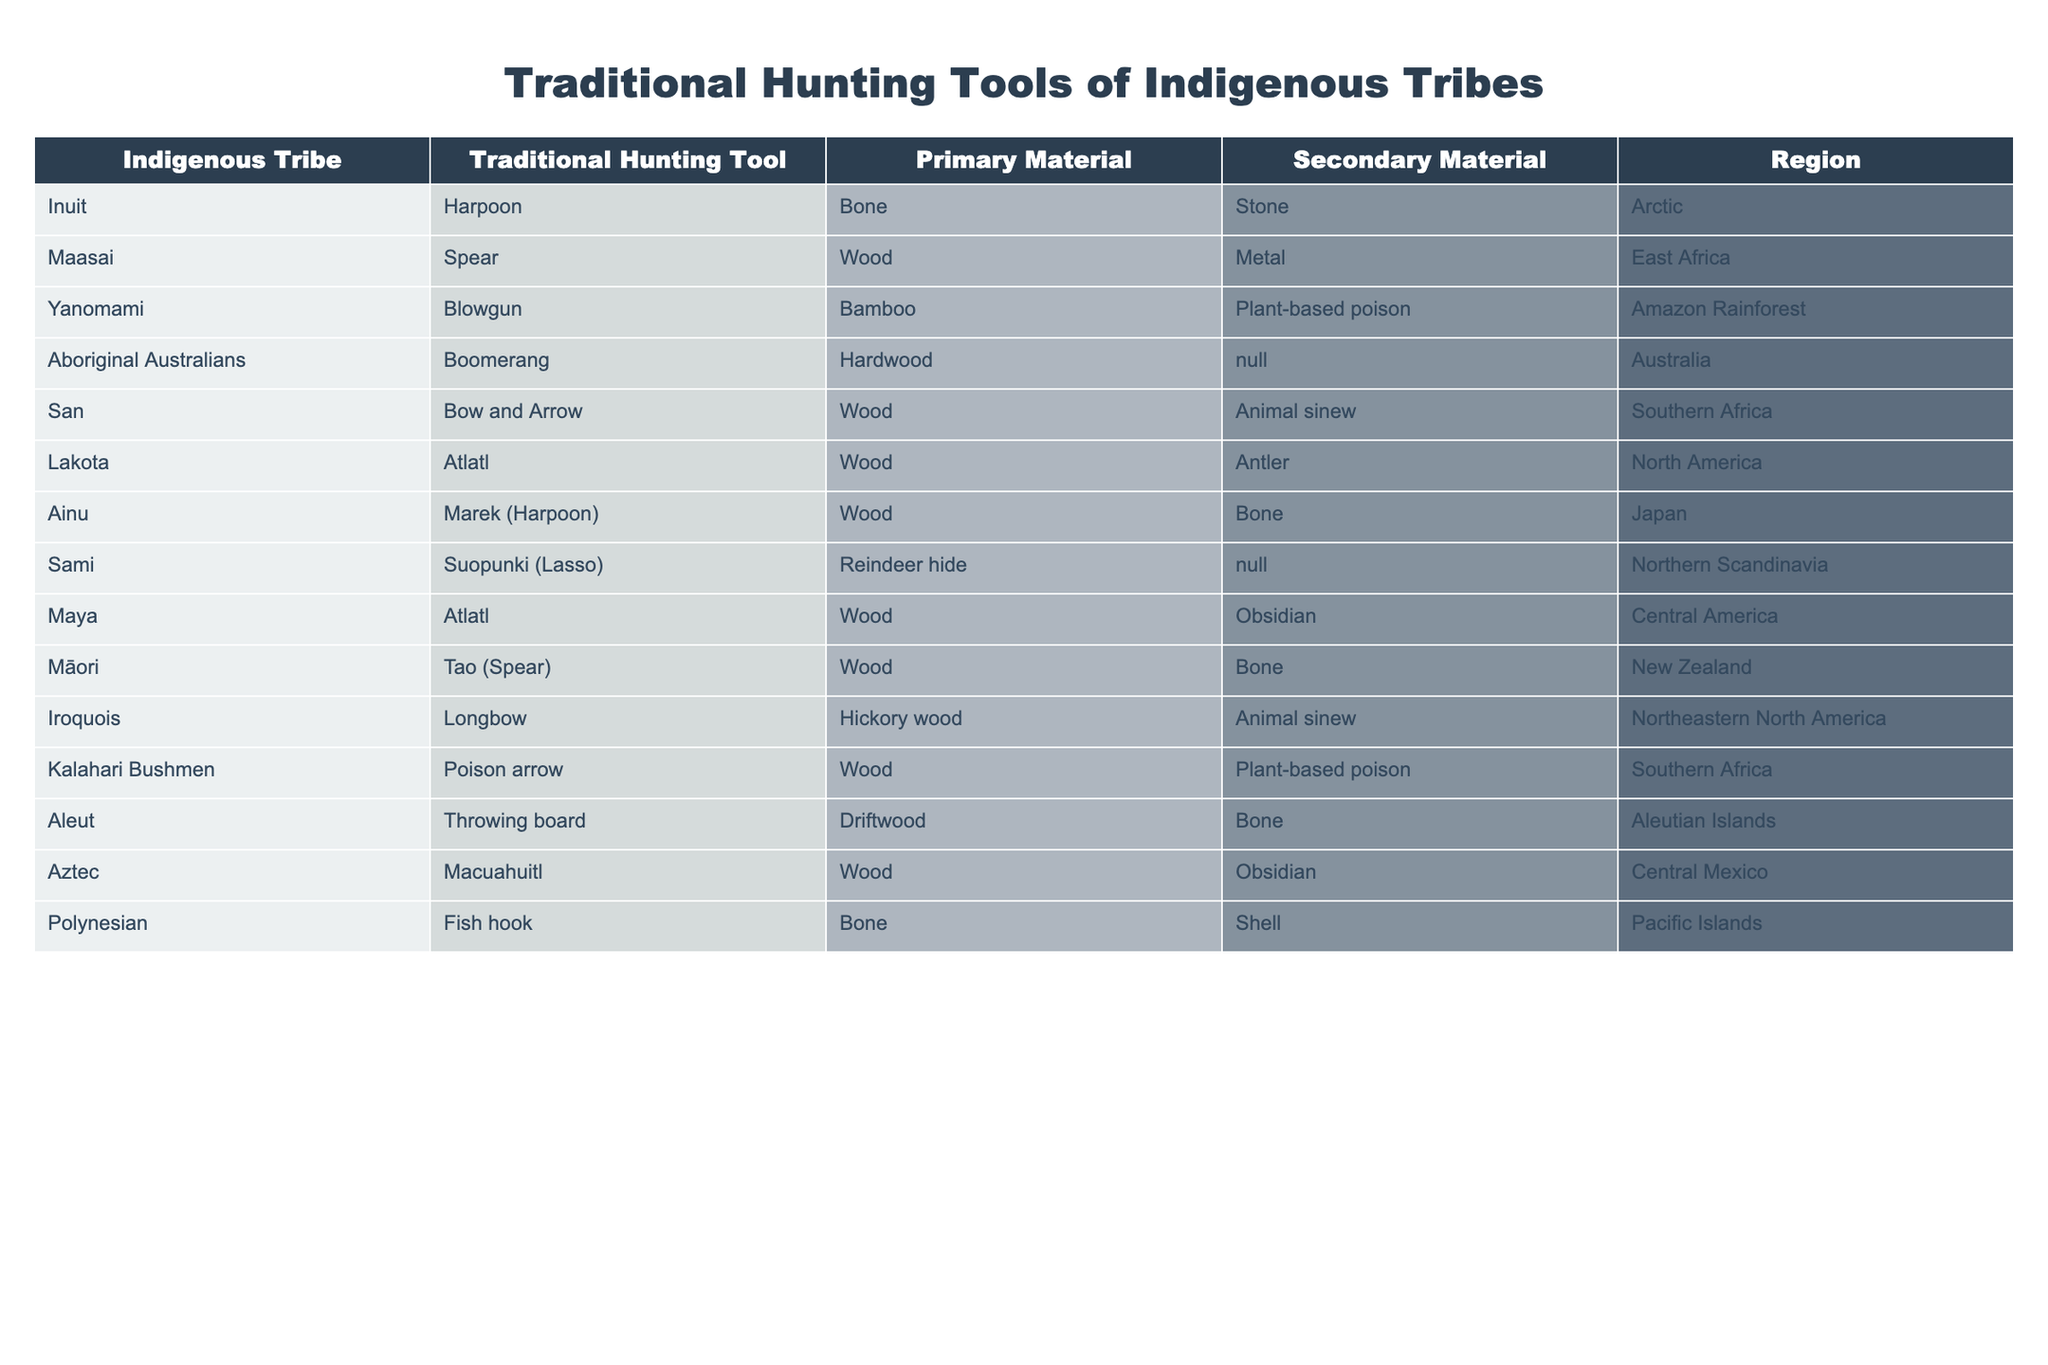What traditional hunting tool is used by the Inuit? The table lists the traditional hunting tools used by various indigenous tribes, and for the Inuit, the specific tool mentioned is the harpoon.
Answer: Harpoon Which material is primarily used for the blowgun by the Yanomami tribe? By looking at the row for the Yanomami tribe, the primary material listed for their traditional blowgun is bamboo.
Answer: Bamboo Are the Sami tribe's traditional tools made from wood? According to the table, the Sami tribe's tool (Suopunki) is made from reindeer hide as the primary material. Therefore, it is not primarily made of wood.
Answer: No How many tribes use wood as a primary material for their traditional hunting tools? By counting the rows in the table, there are 7 tribes (Maasai, San, Lakota, Ainu, Maya, Māori, Iroquois, and Aztec) that use wood as their primary material.
Answer: 7 What is the secondary material used by the Iroquois for their longbow? The table shows that the secondary material for the Iroquois longbow is animal sinew.
Answer: Animal sinew Is it true that all traditional hunting tools in the table are made from natural materials? Upon examining the materials, it is evident that some tools are made from natural materials like wood or bone, while others like metal appear for the Maasai spear, thus, not all are natural.
Answer: No Which region has the highest variety of traditional hunting tools listed in the table? By analyzing the data, the Southern Africa region has two tribes (San and Kalahari Bushmen) using different traditional hunting tools. No other region has more than two listed.
Answer: Southern Africa What is the secondary material used for the spear by the Māori tribe? From the Maori row in the table, it is indicated that the secondary material for the spear (Tao) is bone.
Answer: Bone If we were to group the tribes by the primary material used for their hunting tools, which group would have the most tribes? Counting the tribes: wood is used by 7 tribes, while other materials like bone and metal are used by fewer tribes. Thus, wood is the most common primary material group.
Answer: Wood How many tribes utilize bone as a primary or secondary material in their traditional hunting tools? By analyzing the table, bone is used as a primary material by the Ainu and Polynesian tribes, and as a secondary material by Sami, Māori, and Iroquois. This adds up to 5 tribes.
Answer: 5 